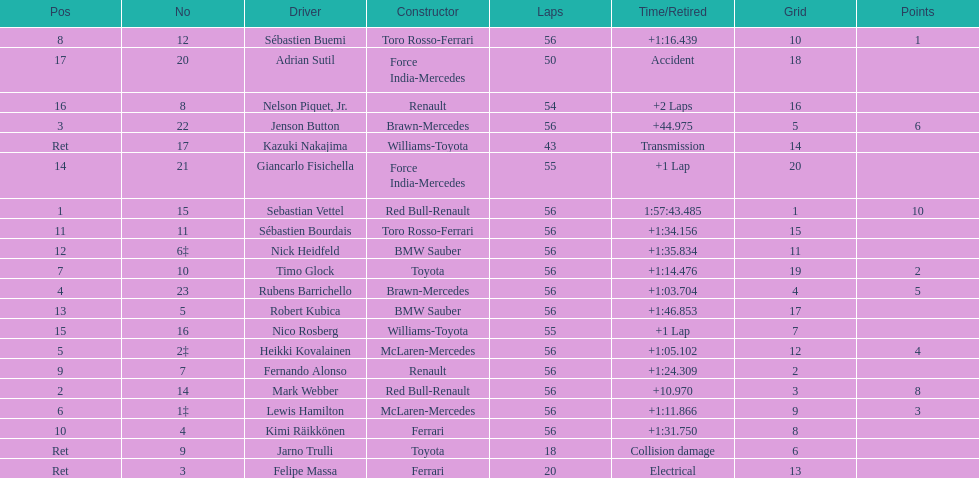How many laps in total is the race? 56. 